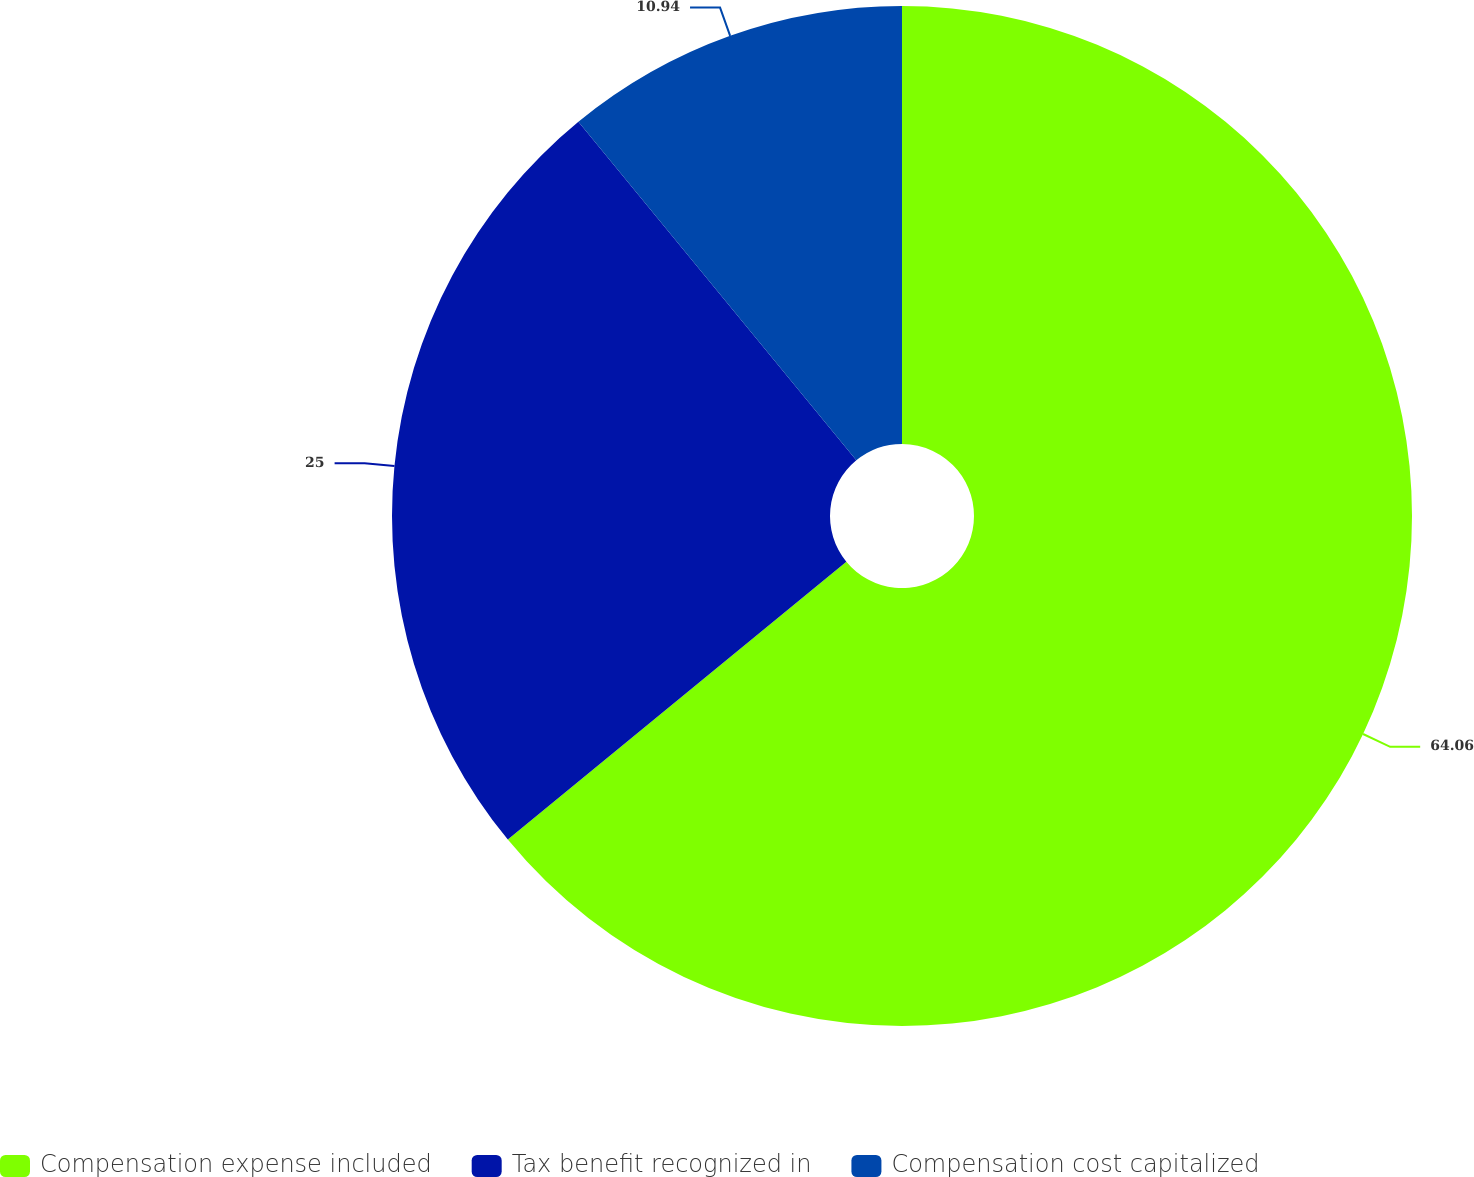Convert chart. <chart><loc_0><loc_0><loc_500><loc_500><pie_chart><fcel>Compensation expense included<fcel>Tax benefit recognized in<fcel>Compensation cost capitalized<nl><fcel>64.06%<fcel>25.0%<fcel>10.94%<nl></chart> 